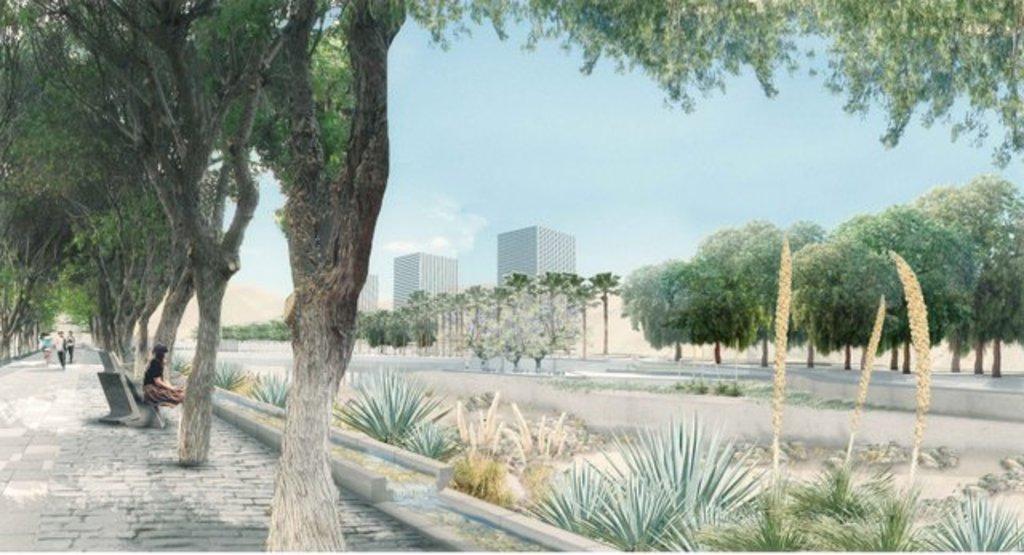Could you give a brief overview of what you see in this image? This is an outside view. On the right side there is a road. On both sides of the road there are many trees and plants. On the left side there are few people walking on the ground and one person is sitting on a bench facing towards the right side. In the background there are few buildings. At the top of the image I can see the sky. 